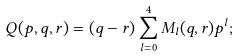<formula> <loc_0><loc_0><loc_500><loc_500>Q ( p , q , r ) = ( q - r ) \sum _ { l = 0 } ^ { 4 } M _ { l } ( q , r ) p ^ { l } ;</formula> 